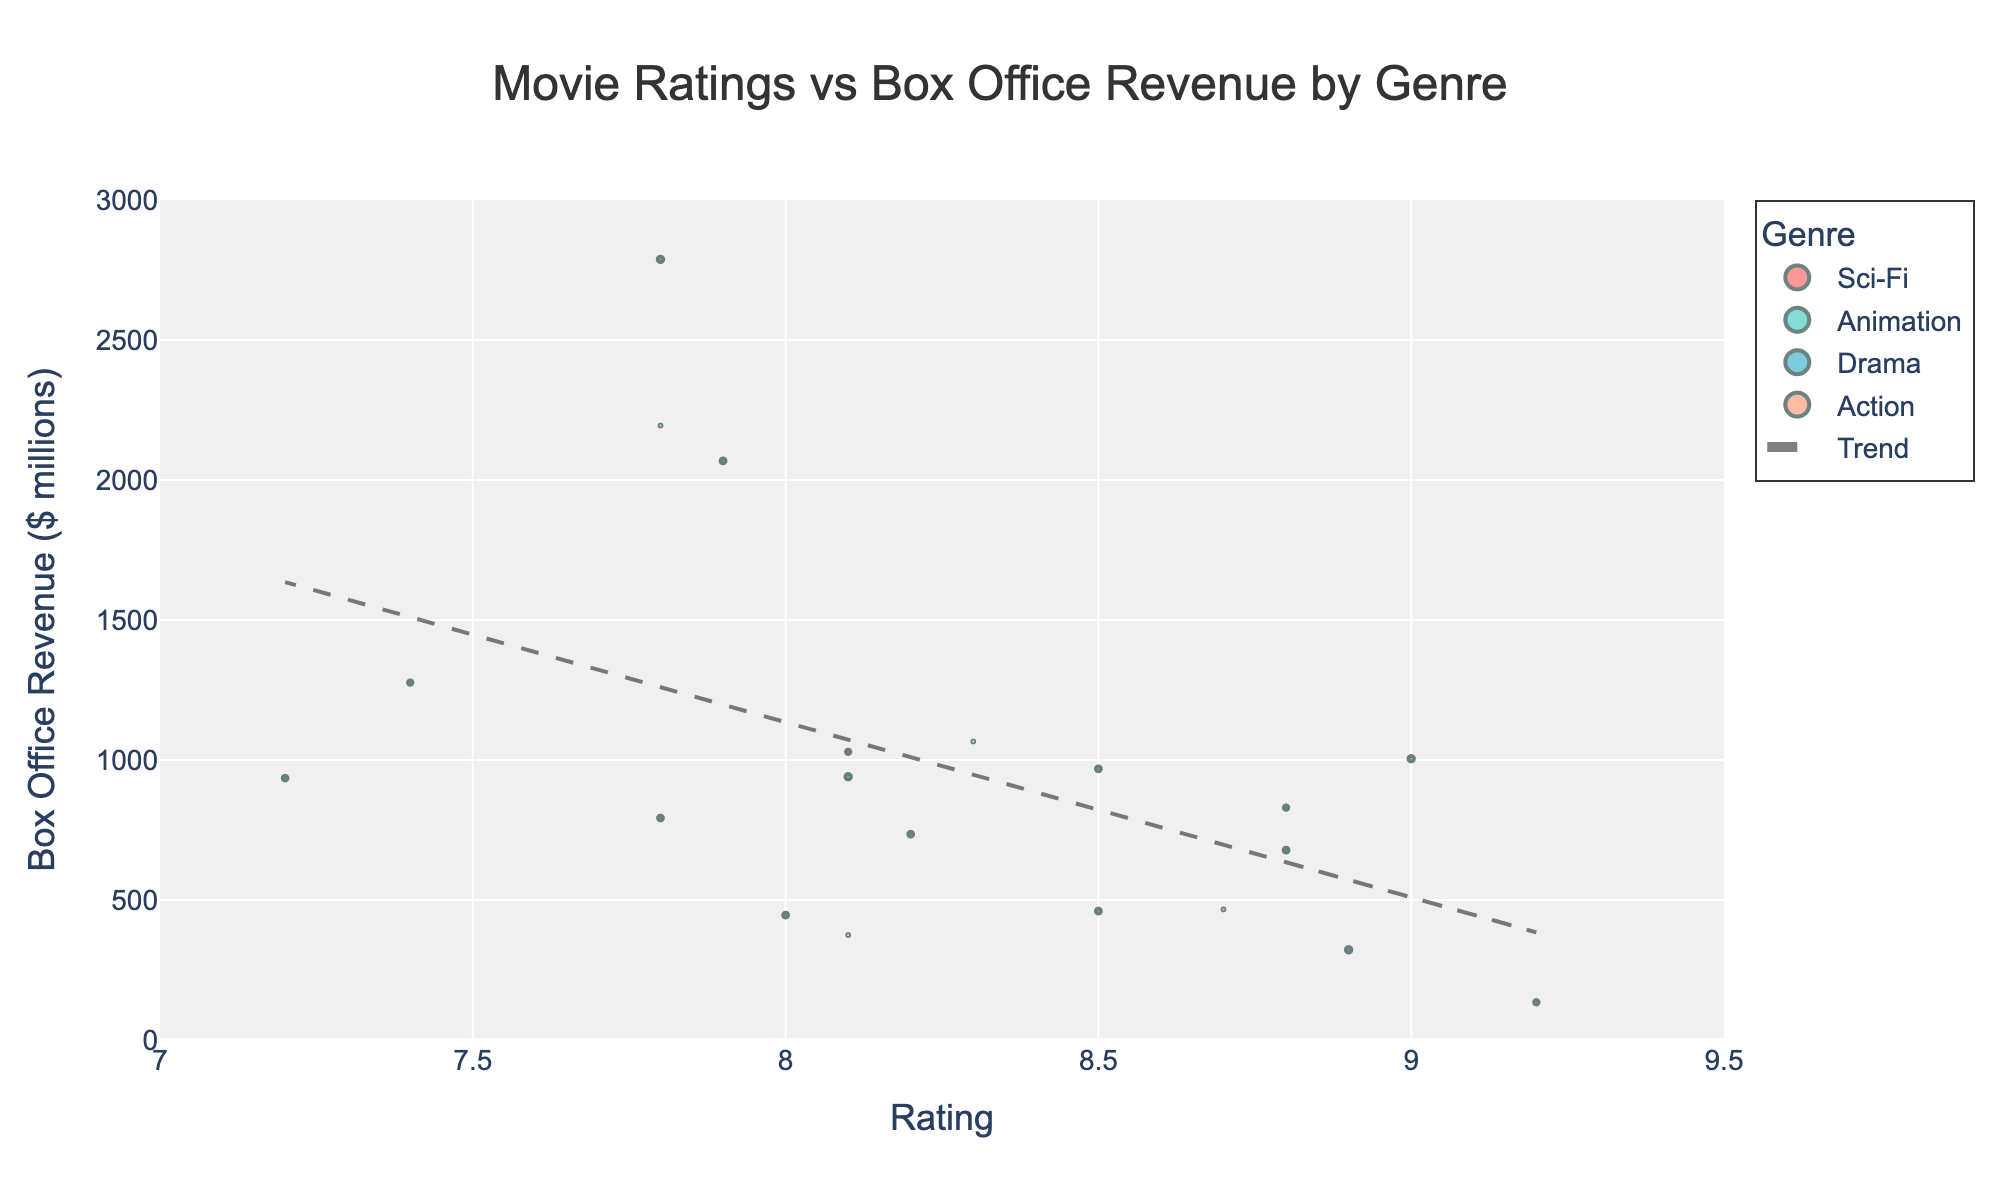What is the title of the plot? The title of the plot is displayed at the top center of the figure in larger font size. It reads: "Movie Ratings vs Box Office Revenue by Genre".
Answer: Movie Ratings vs Box Office Revenue by Genre What does the x-axis represent? The x-axis label is provided at the bottom of the axis. It shows "Rating", representing the movie ratings.
Answer: Rating How many genres are represented in the plot, and what are they? The legend on the right side of the plot lists four different genres: Sci-Fi, Animation, Drama, and Action.
Answer: Four: Sci-Fi, Animation, Drama, and Action What color represents Sci-Fi movies? According to the legend on the right, the color representing Sci-Fi is red.
Answer: Red What is the average box office revenue for Animation movies? The Animation movies in the data are Frozen (1276.5M), Finding Nemo (940.3M), Toy Story 3 (1066.2M), The Lion King (968.5M), Up (735.1M), and Shrek 2 (935.2M). The sum of these revenues is 5921.8M. The average box office revenue is 5921.8M / 6 = approximately 987M.
Answer: 987M Among the movies with a rating of 8.1, what is the total box office revenue? The movies with a rating of 8.1 are Jurassic Park (1029.2M), Finding Nemo (940.3M), and Mad Max: Fury Road (374.7M). Adding these gives a total of 1029.2M + 940.3M + 374.7M = 2344.2M.
Answer: 2344.2M Which movie has the highest box office revenue, and what genre does it belong to? The highest box office revenue in the plot is shown at the top of the y-axis. Avatar has the highest revenue at 2787.9M, and it belongs to the Sci-Fi genre.
Answer: Avatar, Sci-Fi Which genre is associated with the movie that has the highest rating? The movie with the highest rating, 9.2, is The Godfather, which is colored blue. According to the legend, blue represents Drama.
Answer: Drama Is there a positive or negative correlation between movie ratings and box office revenue? The trend line added to the scatter plot indicates the overall trend. The line with a positive slope suggests a positive correlation between movie ratings and box office revenue.
Answer: Positive Do any genres show a different pattern from the others in terms of box office revenue increasing with ratings? By examining the plot, Sci-Fi and Action generally follow the trend line more closely with consistent increases in box office revenue with higher ratings, while Drama and Animation show more variability and do not always increase consistently with ratings. Animation movies like Frozen and Shrek 2 have high revenue but lower ratings.
Answer: Animation and Drama show more variability 